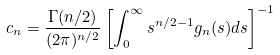<formula> <loc_0><loc_0><loc_500><loc_500>c _ { n } = \frac { \Gamma ( n / 2 ) } { ( 2 \pi ) ^ { n / 2 } } \left [ \int _ { 0 } ^ { \infty } s ^ { n / 2 - 1 } g _ { n } ( s ) d s \right ] ^ { - 1 }</formula> 